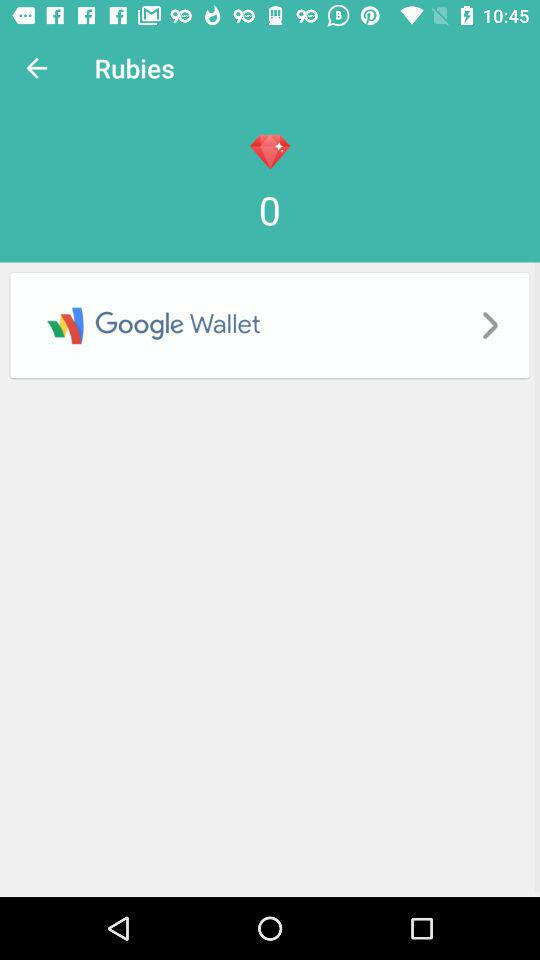How much is in the "Google Wallet"?
When the provided information is insufficient, respond with <no answer>. <no answer> 